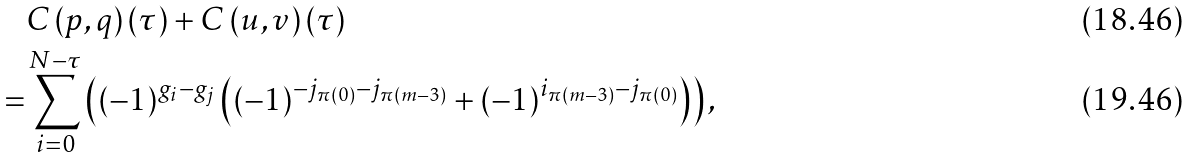<formula> <loc_0><loc_0><loc_500><loc_500>& C \left ( p , q \right ) ( \tau ) + C \left ( u , v \right ) ( \tau ) \\ = & \sum _ { i = 0 } ^ { N - \tau } \left ( ( - 1 ) ^ { g _ { i } - g _ { j } } \left ( ( - 1 ) ^ { - j _ { \pi ( 0 ) } - j _ { \pi ( m - 3 ) } } + ( - 1 ) ^ { i _ { \pi ( m - 3 ) } - j _ { \pi ( 0 ) } } \right ) \right ) ,</formula> 